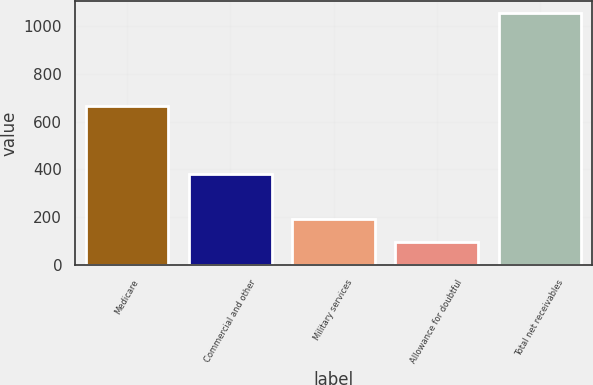Convert chart. <chart><loc_0><loc_0><loc_500><loc_500><bar_chart><fcel>Medicare<fcel>Commercial and other<fcel>Military services<fcel>Allowance for doubtful<fcel>Total net receivables<nl><fcel>664<fcel>381<fcel>193.5<fcel>98<fcel>1053<nl></chart> 